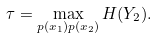Convert formula to latex. <formula><loc_0><loc_0><loc_500><loc_500>\tau = \max _ { p ( x _ { 1 } ) p ( x _ { 2 } ) } H ( Y _ { 2 } ) .</formula> 